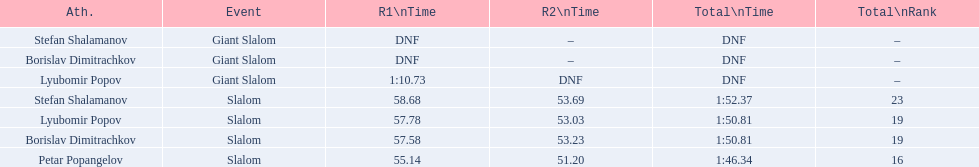Who was the other athlete who tied in rank with lyubomir popov? Borislav Dimitrachkov. 